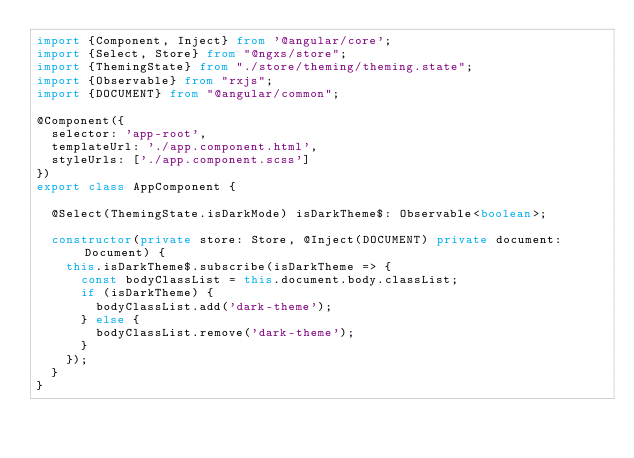Convert code to text. <code><loc_0><loc_0><loc_500><loc_500><_TypeScript_>import {Component, Inject} from '@angular/core';
import {Select, Store} from "@ngxs/store";
import {ThemingState} from "./store/theming/theming.state";
import {Observable} from "rxjs";
import {DOCUMENT} from "@angular/common";

@Component({
  selector: 'app-root',
  templateUrl: './app.component.html',
  styleUrls: ['./app.component.scss']
})
export class AppComponent {

  @Select(ThemingState.isDarkMode) isDarkTheme$: Observable<boolean>;

  constructor(private store: Store, @Inject(DOCUMENT) private document: Document) {
    this.isDarkTheme$.subscribe(isDarkTheme => {
      const bodyClassList = this.document.body.classList;
      if (isDarkTheme) {
        bodyClassList.add('dark-theme');
      } else {
        bodyClassList.remove('dark-theme');
      }
    });
  }
}
</code> 